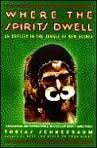What inspired Tobias Schneebaum to write 'Where the Spirits Dwell'? Tobias Schneebaum was inspired by his profound experiences and interactions with the indigenous people of New Guinea, their unique lifestyle and his desire to share these rare insights with the world. 